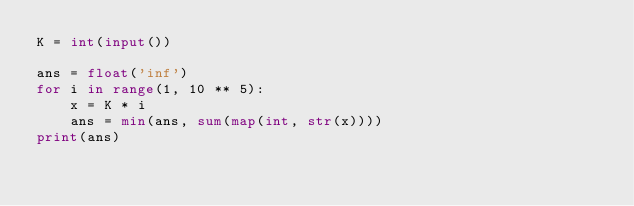Convert code to text. <code><loc_0><loc_0><loc_500><loc_500><_Python_>K = int(input())

ans = float('inf')
for i in range(1, 10 ** 5):
    x = K * i
    ans = min(ans, sum(map(int, str(x))))
print(ans)</code> 